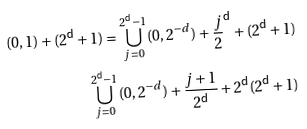<formula> <loc_0><loc_0><loc_500><loc_500>( 0 , 1 ) + { ( 2 ^ { \mathsf d } + 1 ) = \bigcup _ { j = 0 } ^ { 2 ^ { \mathsf d } - 1 } ( 0 , 2 ^ { - d } ) + \frac { j } 2 ^ { \mathsf d } } + { ( 2 ^ { \mathsf d } + 1 ) } \\ \bigcup _ { j = 0 } ^ { 2 ^ { \mathsf d } - 1 } ( 0 , 2 ^ { - d } ) + \frac { j + 1 } { 2 ^ { \mathsf d } } + { 2 ^ { \mathsf d } ( 2 ^ { \mathsf d } + 1 ) }</formula> 